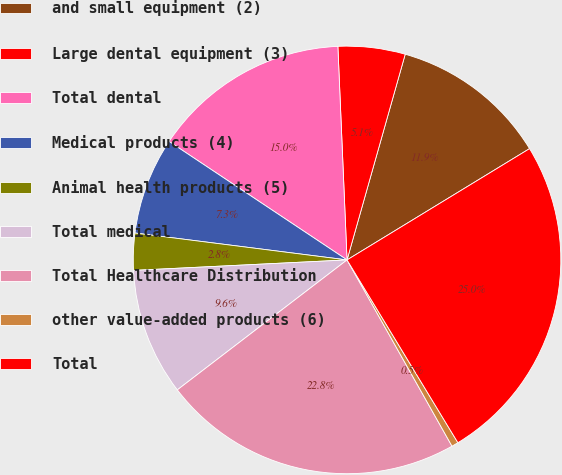Convert chart to OTSL. <chart><loc_0><loc_0><loc_500><loc_500><pie_chart><fcel>and small equipment (2)<fcel>Large dental equipment (3)<fcel>Total dental<fcel>Medical products (4)<fcel>Animal health products (5)<fcel>Total medical<fcel>Total Healthcare Distribution<fcel>other value-added products (6)<fcel>Total<nl><fcel>11.9%<fcel>5.07%<fcel>14.97%<fcel>7.34%<fcel>2.79%<fcel>9.62%<fcel>22.77%<fcel>0.51%<fcel>25.04%<nl></chart> 